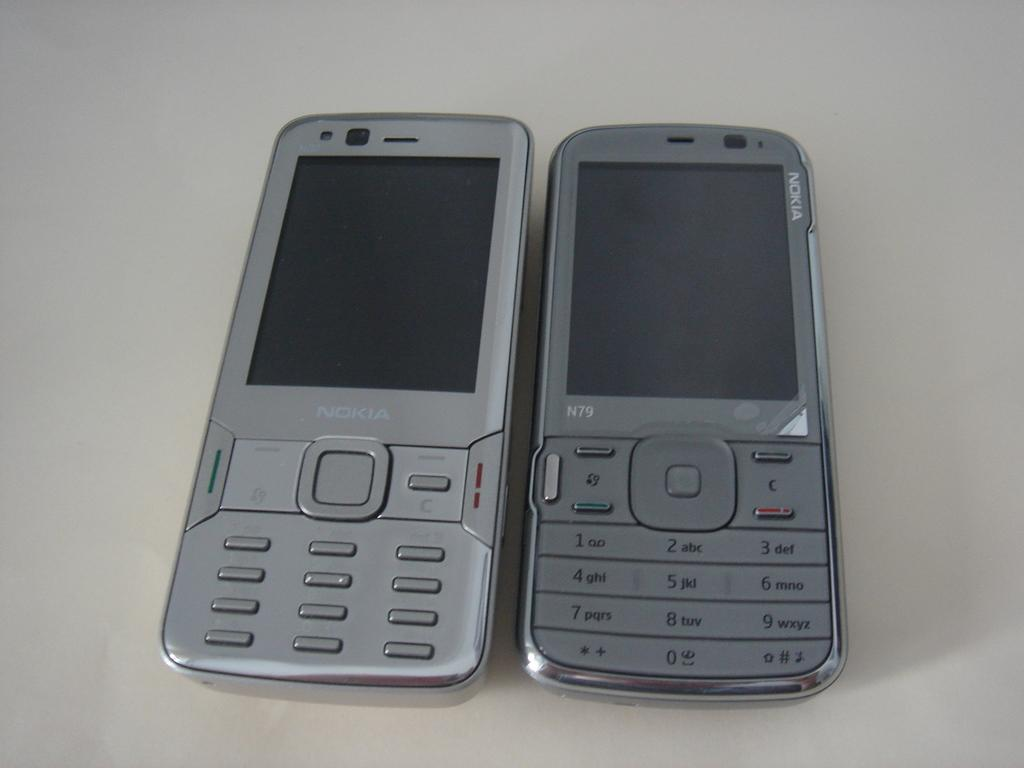Provide a one-sentence caption for the provided image. Light grey Nokia next to a darker colored Nokia phone modeled N79. 